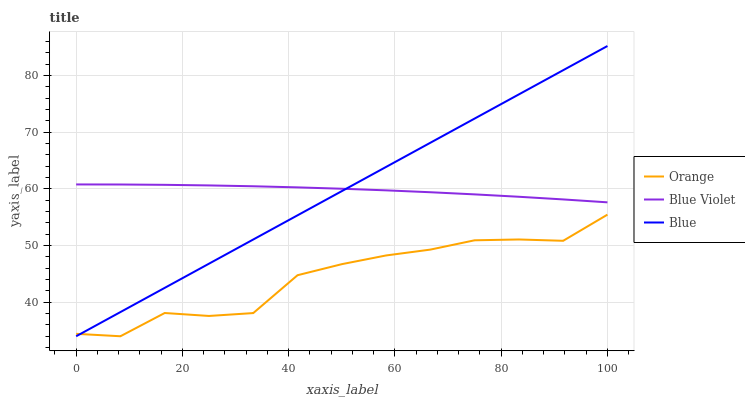Does Orange have the minimum area under the curve?
Answer yes or no. Yes. Does Blue Violet have the maximum area under the curve?
Answer yes or no. Yes. Does Blue have the minimum area under the curve?
Answer yes or no. No. Does Blue have the maximum area under the curve?
Answer yes or no. No. Is Blue the smoothest?
Answer yes or no. Yes. Is Orange the roughest?
Answer yes or no. Yes. Is Blue Violet the smoothest?
Answer yes or no. No. Is Blue Violet the roughest?
Answer yes or no. No. Does Orange have the lowest value?
Answer yes or no. Yes. Does Blue Violet have the lowest value?
Answer yes or no. No. Does Blue have the highest value?
Answer yes or no. Yes. Does Blue Violet have the highest value?
Answer yes or no. No. Is Orange less than Blue Violet?
Answer yes or no. Yes. Is Blue Violet greater than Orange?
Answer yes or no. Yes. Does Blue intersect Orange?
Answer yes or no. Yes. Is Blue less than Orange?
Answer yes or no. No. Is Blue greater than Orange?
Answer yes or no. No. Does Orange intersect Blue Violet?
Answer yes or no. No. 